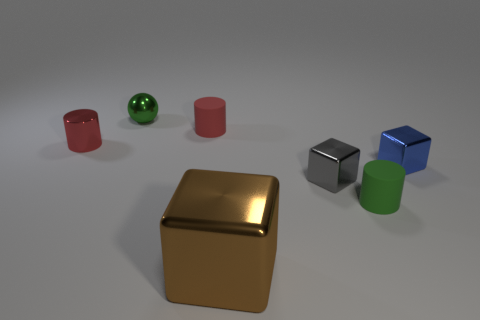There is a cylinder on the right side of the matte cylinder that is behind the gray cube; what is its material? The cylinder on the right side of the matte cylinder behind the gray cube appears to have a shiny surface that suggests it is made of a polished, reflective metal, contrary to the provided answer of 'rubber'. 